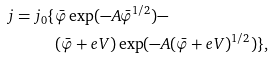Convert formula to latex. <formula><loc_0><loc_0><loc_500><loc_500>j = j _ { 0 } \{ & \bar { \varphi } \exp ( - A \bar { \varphi } ^ { 1 / 2 } ) - \\ & ( \bar { \varphi } + e V ) \exp ( - A ( \bar { \varphi } + e V ) ^ { 1 / 2 } ) \} ,</formula> 